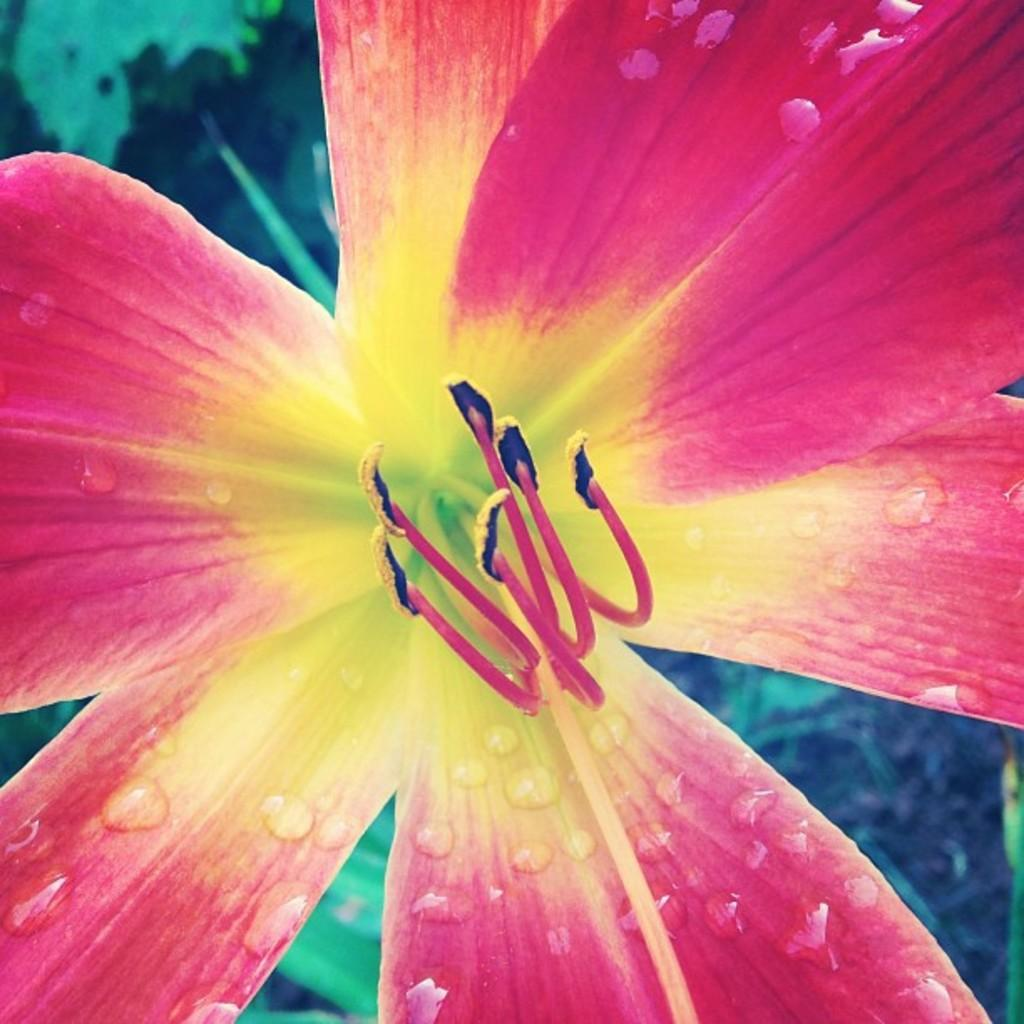What is the main subject of the picture? There is a flower in the picture. Can you describe the background of the picture? The background of the picture is blurry. What type of pear is hanging from the flower in the picture? There is no pear present in the picture; it features a flower with a blurry background. 